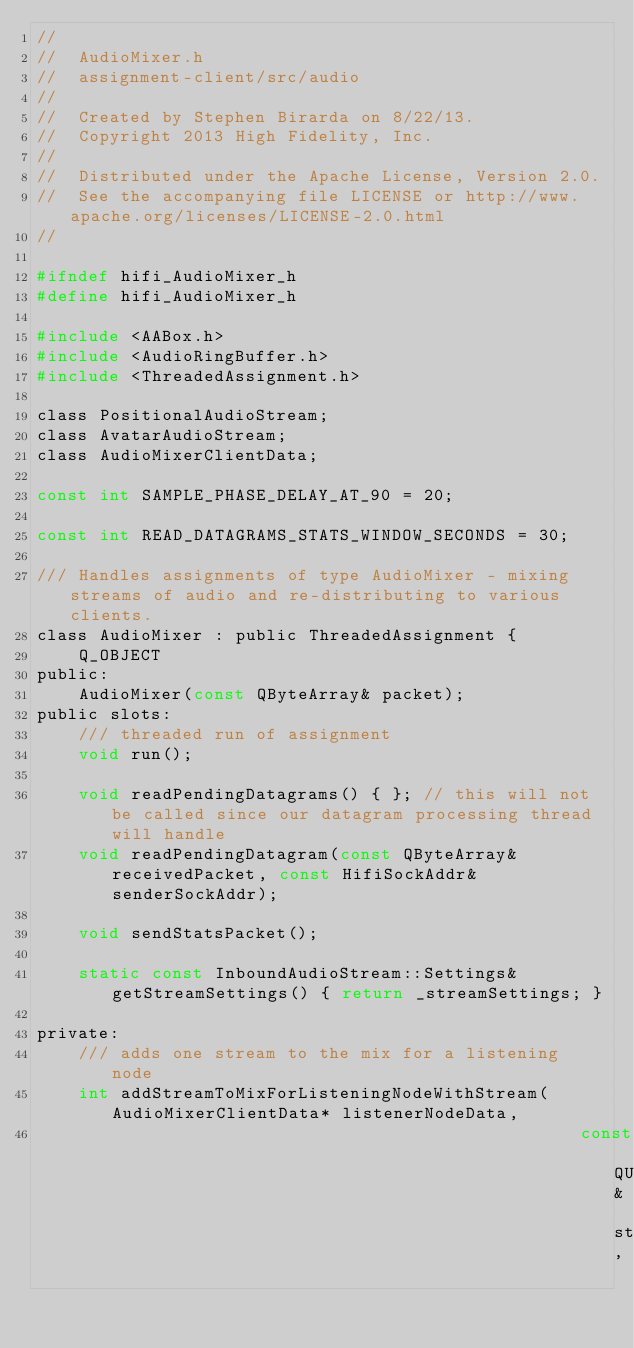<code> <loc_0><loc_0><loc_500><loc_500><_C_>//
//  AudioMixer.h
//  assignment-client/src/audio
//
//  Created by Stephen Birarda on 8/22/13.
//  Copyright 2013 High Fidelity, Inc.
//
//  Distributed under the Apache License, Version 2.0.
//  See the accompanying file LICENSE or http://www.apache.org/licenses/LICENSE-2.0.html
//

#ifndef hifi_AudioMixer_h
#define hifi_AudioMixer_h

#include <AABox.h>
#include <AudioRingBuffer.h>
#include <ThreadedAssignment.h>

class PositionalAudioStream;
class AvatarAudioStream;
class AudioMixerClientData;

const int SAMPLE_PHASE_DELAY_AT_90 = 20;

const int READ_DATAGRAMS_STATS_WINDOW_SECONDS = 30;

/// Handles assignments of type AudioMixer - mixing streams of audio and re-distributing to various clients.
class AudioMixer : public ThreadedAssignment {
    Q_OBJECT
public:
    AudioMixer(const QByteArray& packet);
public slots:
    /// threaded run of assignment
    void run();
    
    void readPendingDatagrams() { }; // this will not be called since our datagram processing thread will handle
    void readPendingDatagram(const QByteArray& receivedPacket, const HifiSockAddr& senderSockAddr);
    
    void sendStatsPacket();

    static const InboundAudioStream::Settings& getStreamSettings() { return _streamSettings; }
    
private:
    /// adds one stream to the mix for a listening node
    int addStreamToMixForListeningNodeWithStream(AudioMixerClientData* listenerNodeData,
                                                    const QUuid& streamUUID,</code> 